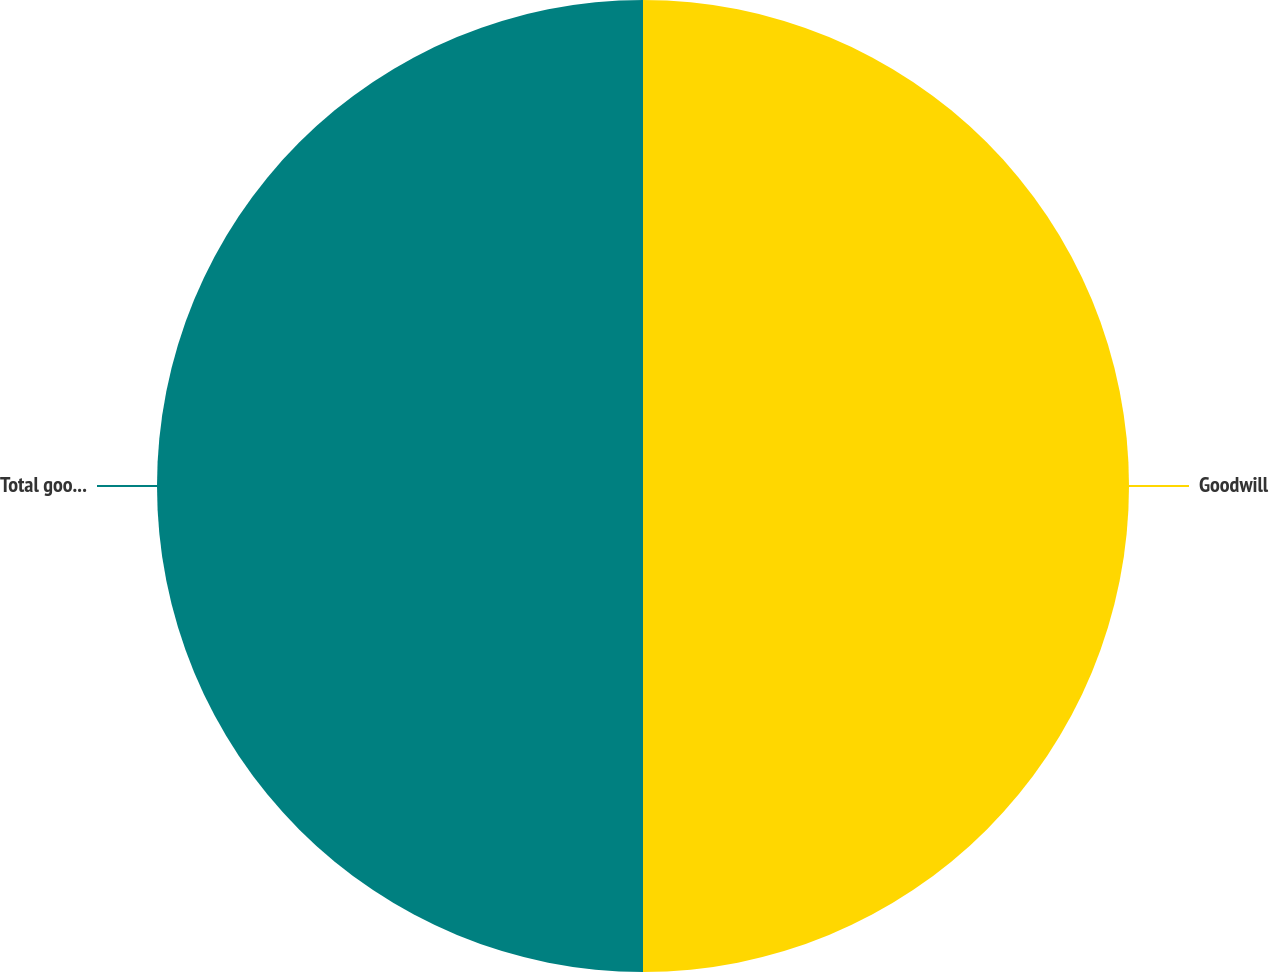Convert chart to OTSL. <chart><loc_0><loc_0><loc_500><loc_500><pie_chart><fcel>Goodwill<fcel>Total goodwill net<nl><fcel>50.0%<fcel>50.0%<nl></chart> 